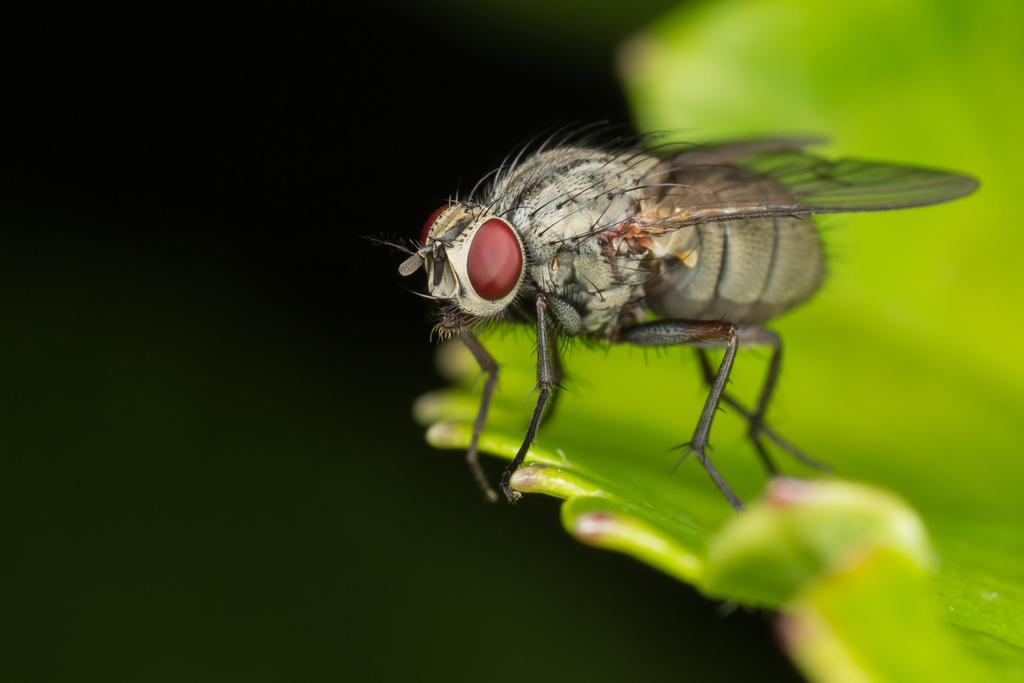What type of insect is in the image? There is a brown bee in the image. What color is the bee's eye? The bee has a red eye. Where is the bee located in the image? The bee is sitting on a green leaf. What type of station is visible in the image? There is no station present in the image; it features a brown bee with a red eye sitting on a green leaf. 